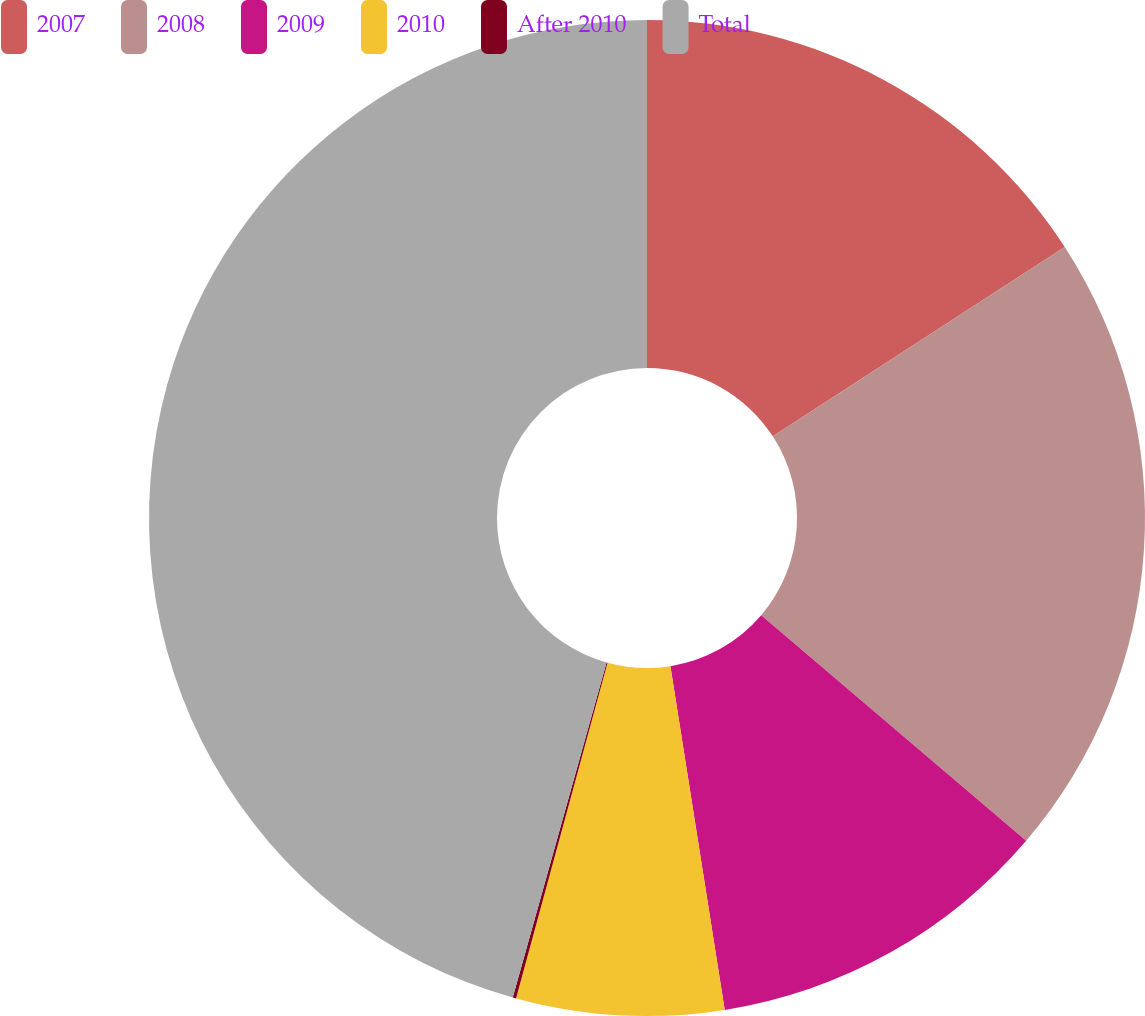Convert chart to OTSL. <chart><loc_0><loc_0><loc_500><loc_500><pie_chart><fcel>2007<fcel>2008<fcel>2009<fcel>2010<fcel>After 2010<fcel>Total<nl><fcel>15.84%<fcel>20.39%<fcel>11.28%<fcel>6.73%<fcel>0.11%<fcel>45.66%<nl></chart> 